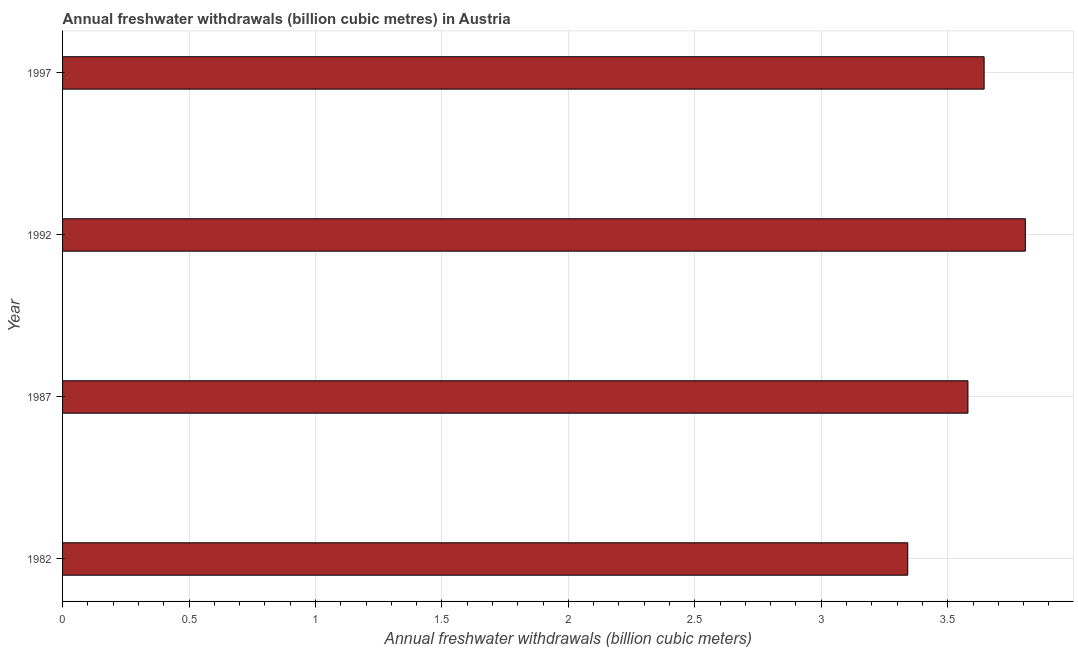Does the graph contain grids?
Ensure brevity in your answer.  Yes. What is the title of the graph?
Give a very brief answer. Annual freshwater withdrawals (billion cubic metres) in Austria. What is the label or title of the X-axis?
Ensure brevity in your answer.  Annual freshwater withdrawals (billion cubic meters). What is the label or title of the Y-axis?
Keep it short and to the point. Year. What is the annual freshwater withdrawals in 1982?
Provide a short and direct response. 3.34. Across all years, what is the maximum annual freshwater withdrawals?
Keep it short and to the point. 3.81. Across all years, what is the minimum annual freshwater withdrawals?
Provide a short and direct response. 3.34. What is the sum of the annual freshwater withdrawals?
Provide a succinct answer. 14.37. What is the difference between the annual freshwater withdrawals in 1982 and 1992?
Provide a succinct answer. -0.47. What is the average annual freshwater withdrawals per year?
Make the answer very short. 3.59. What is the median annual freshwater withdrawals?
Your answer should be very brief. 3.61. What is the ratio of the annual freshwater withdrawals in 1982 to that in 1987?
Offer a very short reply. 0.93. Is the annual freshwater withdrawals in 1992 less than that in 1997?
Provide a succinct answer. No. Is the difference between the annual freshwater withdrawals in 1987 and 1997 greater than the difference between any two years?
Provide a short and direct response. No. What is the difference between the highest and the second highest annual freshwater withdrawals?
Provide a short and direct response. 0.16. What is the difference between the highest and the lowest annual freshwater withdrawals?
Offer a terse response. 0.46. In how many years, is the annual freshwater withdrawals greater than the average annual freshwater withdrawals taken over all years?
Your answer should be compact. 2. How many bars are there?
Keep it short and to the point. 4. Are all the bars in the graph horizontal?
Provide a succinct answer. Yes. Are the values on the major ticks of X-axis written in scientific E-notation?
Your answer should be very brief. No. What is the Annual freshwater withdrawals (billion cubic meters) in 1982?
Your response must be concise. 3.34. What is the Annual freshwater withdrawals (billion cubic meters) in 1987?
Provide a succinct answer. 3.58. What is the Annual freshwater withdrawals (billion cubic meters) of 1992?
Offer a terse response. 3.81. What is the Annual freshwater withdrawals (billion cubic meters) in 1997?
Keep it short and to the point. 3.64. What is the difference between the Annual freshwater withdrawals (billion cubic meters) in 1982 and 1987?
Provide a succinct answer. -0.24. What is the difference between the Annual freshwater withdrawals (billion cubic meters) in 1982 and 1992?
Offer a terse response. -0.47. What is the difference between the Annual freshwater withdrawals (billion cubic meters) in 1982 and 1997?
Offer a terse response. -0.3. What is the difference between the Annual freshwater withdrawals (billion cubic meters) in 1987 and 1992?
Ensure brevity in your answer.  -0.23. What is the difference between the Annual freshwater withdrawals (billion cubic meters) in 1987 and 1997?
Offer a terse response. -0.06. What is the difference between the Annual freshwater withdrawals (billion cubic meters) in 1992 and 1997?
Give a very brief answer. 0.16. What is the ratio of the Annual freshwater withdrawals (billion cubic meters) in 1982 to that in 1987?
Your answer should be compact. 0.93. What is the ratio of the Annual freshwater withdrawals (billion cubic meters) in 1982 to that in 1992?
Your answer should be compact. 0.88. What is the ratio of the Annual freshwater withdrawals (billion cubic meters) in 1982 to that in 1997?
Your answer should be very brief. 0.92. What is the ratio of the Annual freshwater withdrawals (billion cubic meters) in 1992 to that in 1997?
Give a very brief answer. 1.04. 